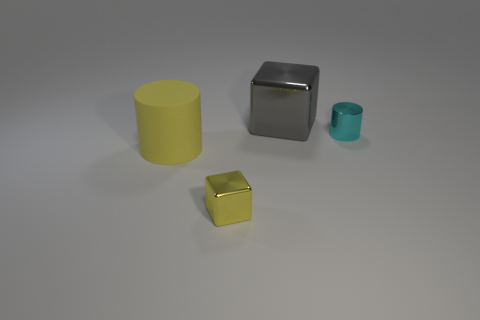Add 3 big gray objects. How many objects exist? 7 Add 1 yellow matte cylinders. How many yellow matte cylinders are left? 2 Add 4 green balls. How many green balls exist? 4 Subtract 0 purple cubes. How many objects are left? 4 Subtract all yellow metallic objects. Subtract all gray objects. How many objects are left? 2 